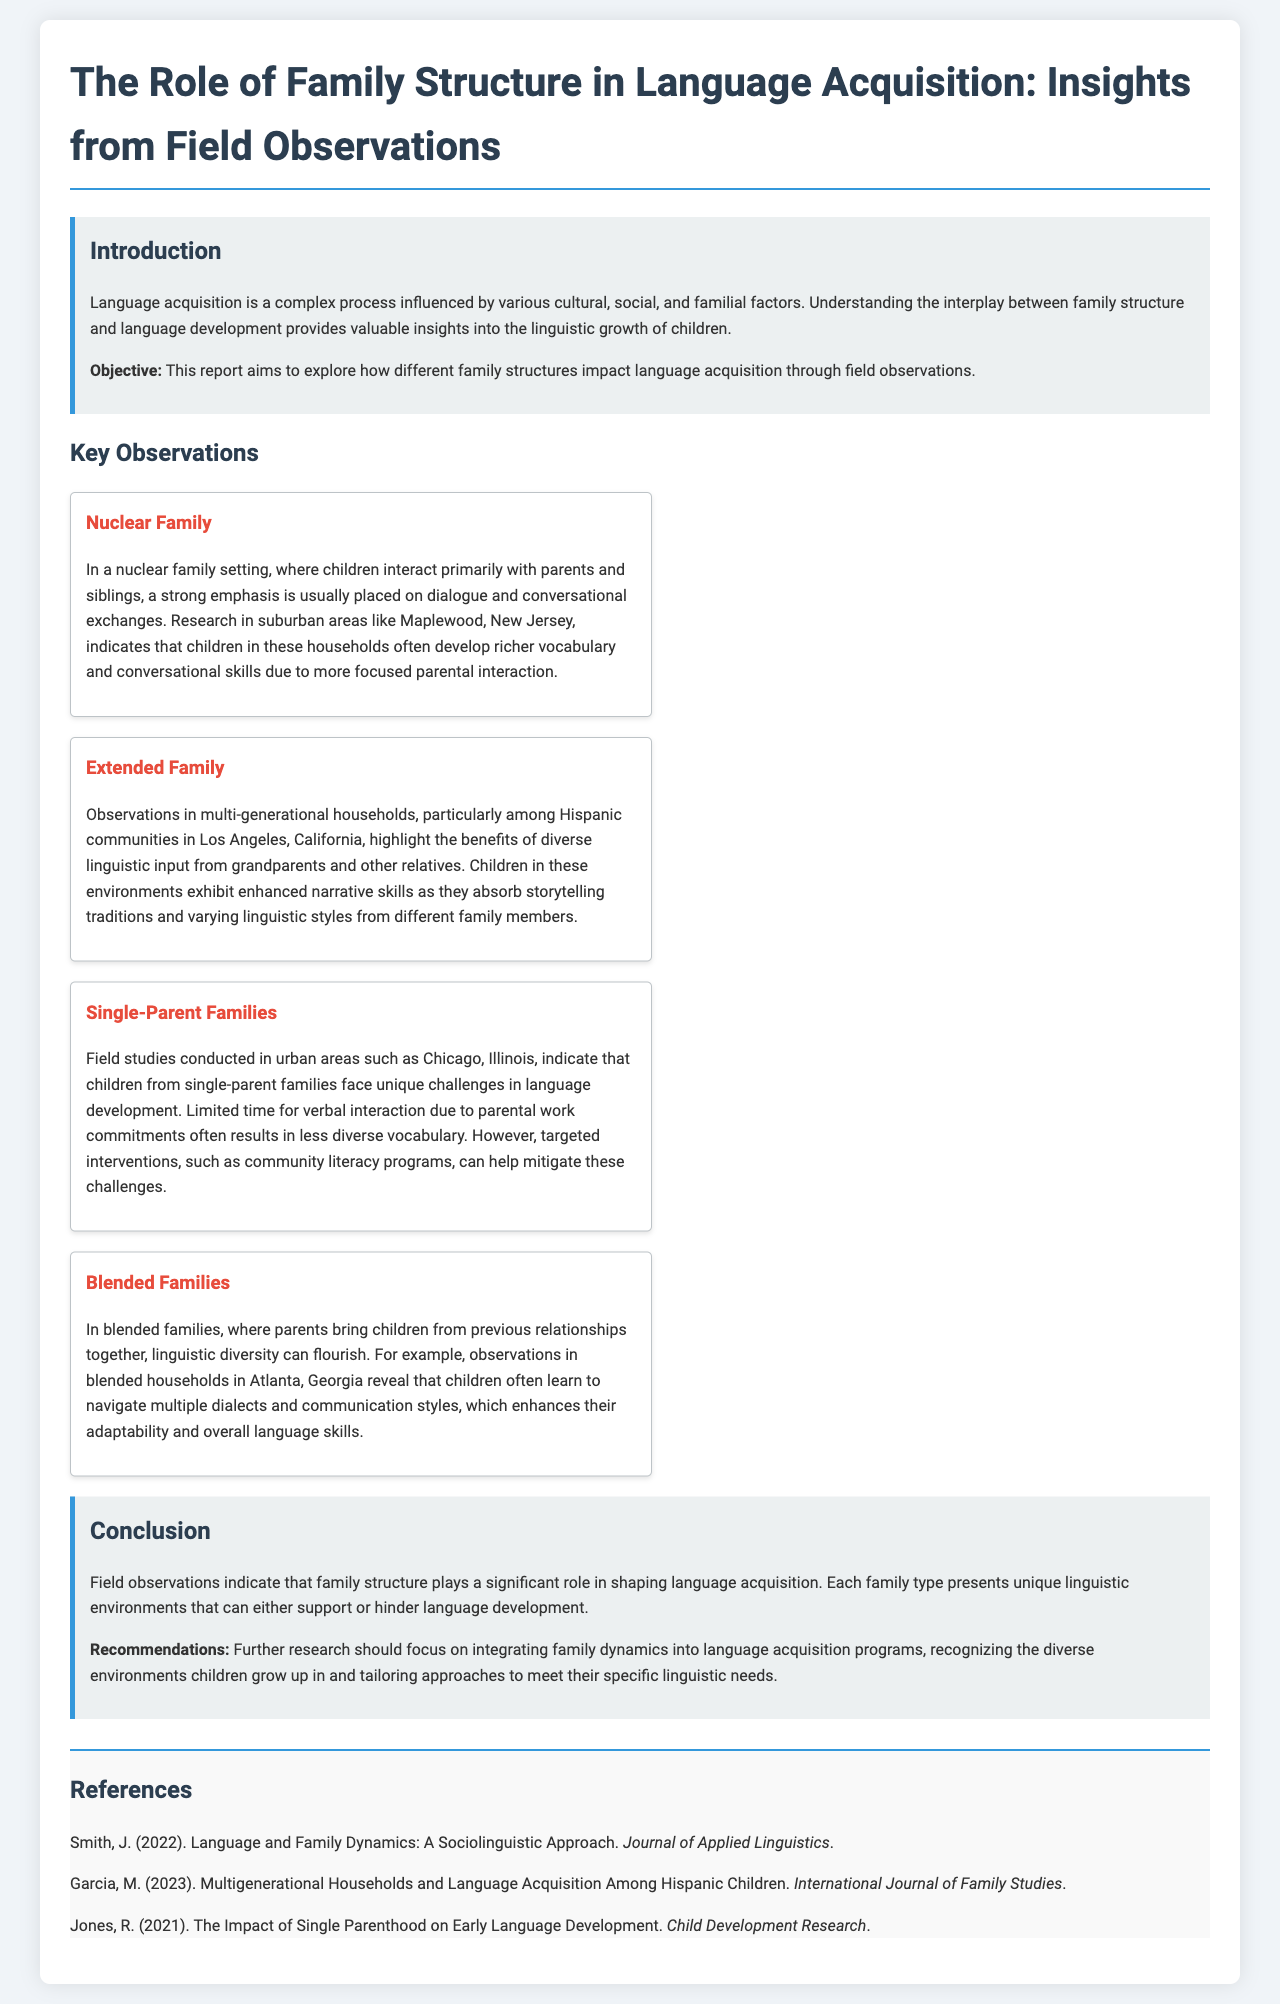What is the primary focus of the report? The report primarily focuses on exploring how different family structures impact language acquisition through field observations.
Answer: Family structures and language acquisition What specific family structure was observed in Maplewood, New Jersey? The observation focused on the nuclear family structure and its impact on children's vocabulary and conversational skills.
Answer: Nuclear Family Which community in Los Angeles was studied for extended family structures? The study centered around multi-generational households in Hispanic communities.
Answer: Hispanic communities What unique challenges do children from single-parent families face? Children from single-parent families face unique challenges due to limited time for verbal interaction, impacting their vocabulary diversity.
Answer: Limited verbal interaction What can help mitigate challenges in language development for children in single-parent families? Targeted interventions, such as community literacy programs, can help mitigate these challenges.
Answer: Community literacy programs Which family structure was highlighted for promoting linguistic diversity? The blended family structure promotes linguistic diversity as children navigate multiple dialects and communication styles.
Answer: Blended families What is a key recommendation from the report for future research? Further research should focus on integrating family dynamics into language acquisition programs.
Answer: Integrating family dynamics In which city were observations conducted regarding blended families? Observations of blended families were conducted in Atlanta, Georgia.
Answer: Atlanta, Georgia What skills do children in extended families enhance through storytelling traditions? Children in extended families enhance their narrative skills through storytelling traditions and varying linguistic styles.
Answer: Narrative skills 